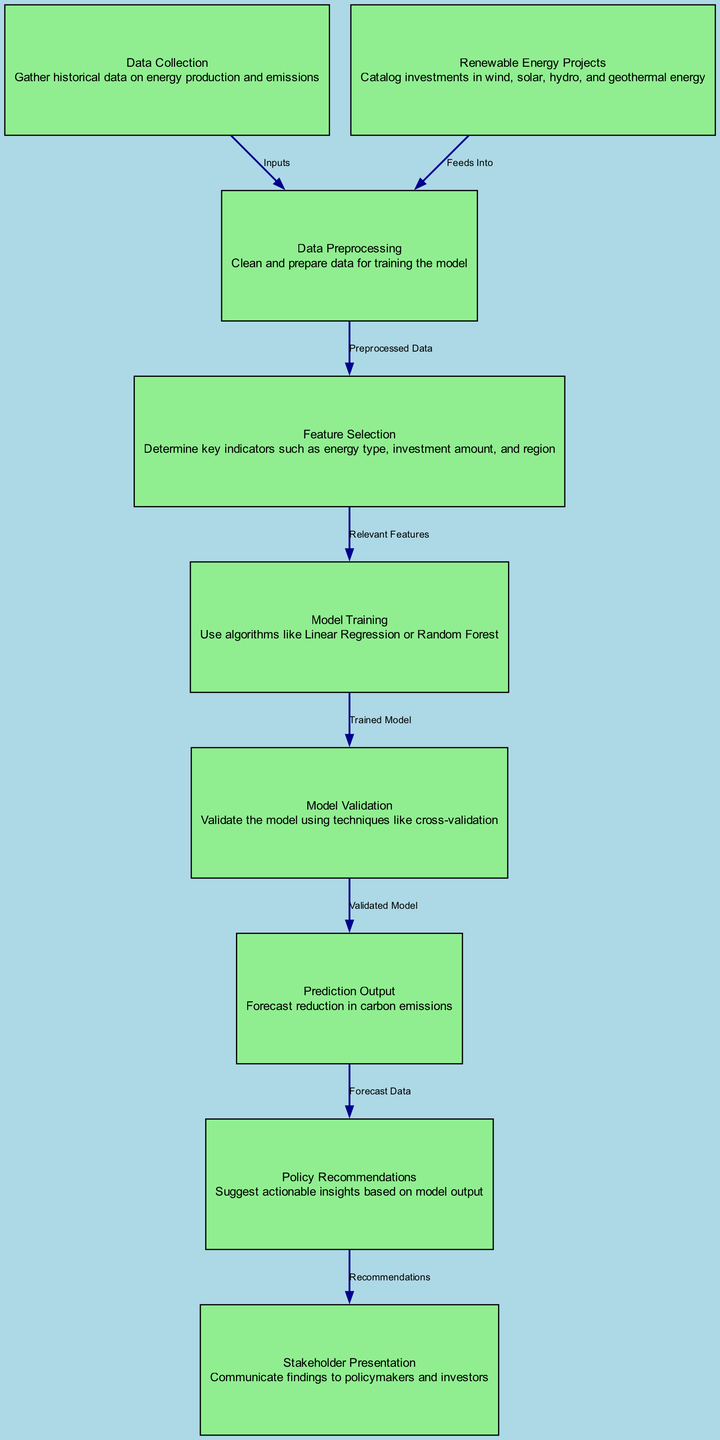What is the first step in the diagram? The first step according to the diagram is "Data Collection", which is the initial node for gathering historical data on energy production and emissions.
Answer: Data Collection How many nodes are in the diagram? The diagram contains nine different nodes, each representing a distinct step in the machine learning model process.
Answer: Nine What is the last step before the "Stakeholder Presentation"? The last step before the "Stakeholder Presentation" is "Policy Recommendations", as indicated by the flow of the diagram that moves from the model output to actionable insights.
Answer: Policy Recommendations Which node directly connects to "Model Validation"? The node that directly connects to "Model Validation" is "Model Training", showing the progression from training the model to validating its performance with techniques like cross-validation.
Answer: Model Training What is the output of the model according to the diagram? The output of the model, indicated by the "Prediction Output" node, is the "Forecast reduction in carbon emissions" from the trained and validated model.
Answer: Forecast reduction in carbon emissions How do the "Renewable Energy Projects" contribute to the diagram? "Renewable Energy Projects" feed into the "Data Preprocessing" step, indicating that investments in renewable energy are part of the data that will be processed to inform the model.
Answer: Feed Into What technique is used during "Model Validation"? "Model Validation" involves using techniques like cross-validation, which ensures that the model's performance is robust and reliable before making predictions.
Answer: Cross-validation What indicates the relationship between "Feature Selection" and "Model Training"? The relationship between "Feature Selection" and "Model Training" is represented by an edge labeled "Relevant Features", which indicates that selected features are input to the model training process.
Answer: Relevant Features Which step suggests interaction with policymakers and investors? The step that suggests interaction with policymakers and investors is "Stakeholder Presentation", through which the findings are communicated effectively to those involved.
Answer: Stakeholder Presentation 